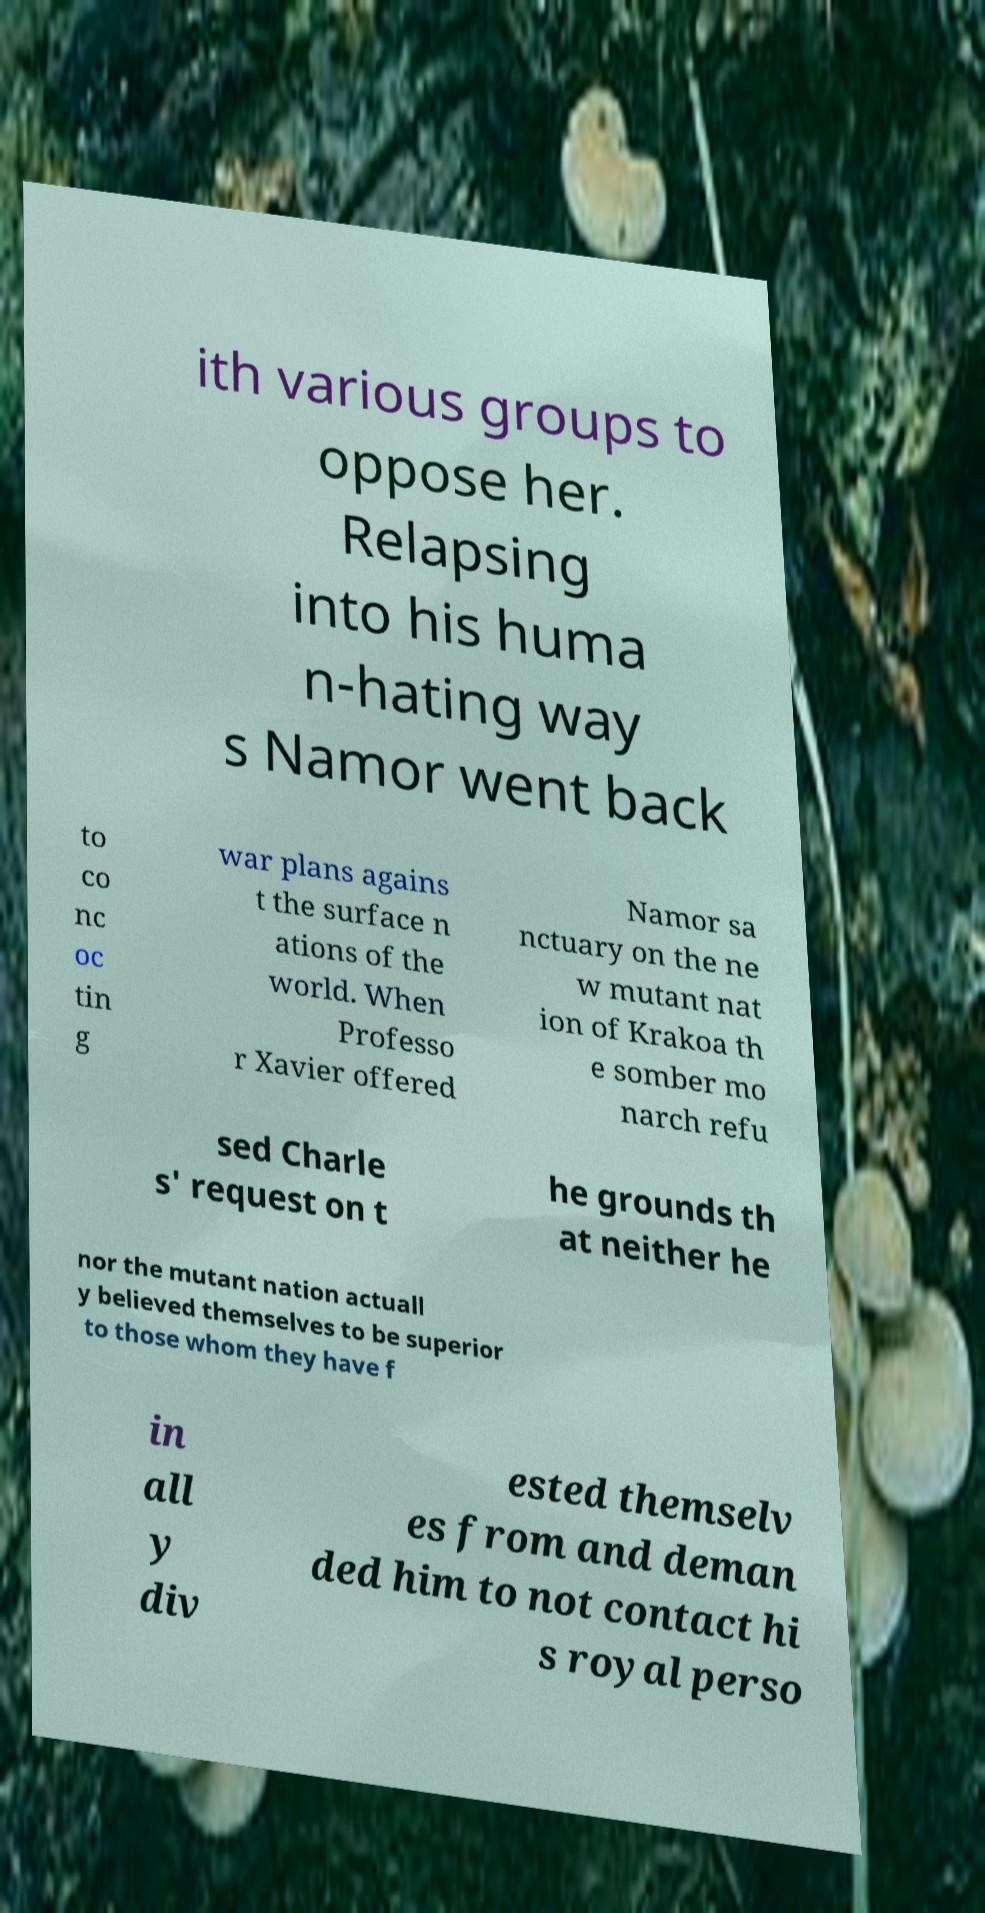Please read and relay the text visible in this image. What does it say? ith various groups to oppose her. Relapsing into his huma n-hating way s Namor went back to co nc oc tin g war plans agains t the surface n ations of the world. When Professo r Xavier offered Namor sa nctuary on the ne w mutant nat ion of Krakoa th e somber mo narch refu sed Charle s' request on t he grounds th at neither he nor the mutant nation actuall y believed themselves to be superior to those whom they have f in all y div ested themselv es from and deman ded him to not contact hi s royal perso 